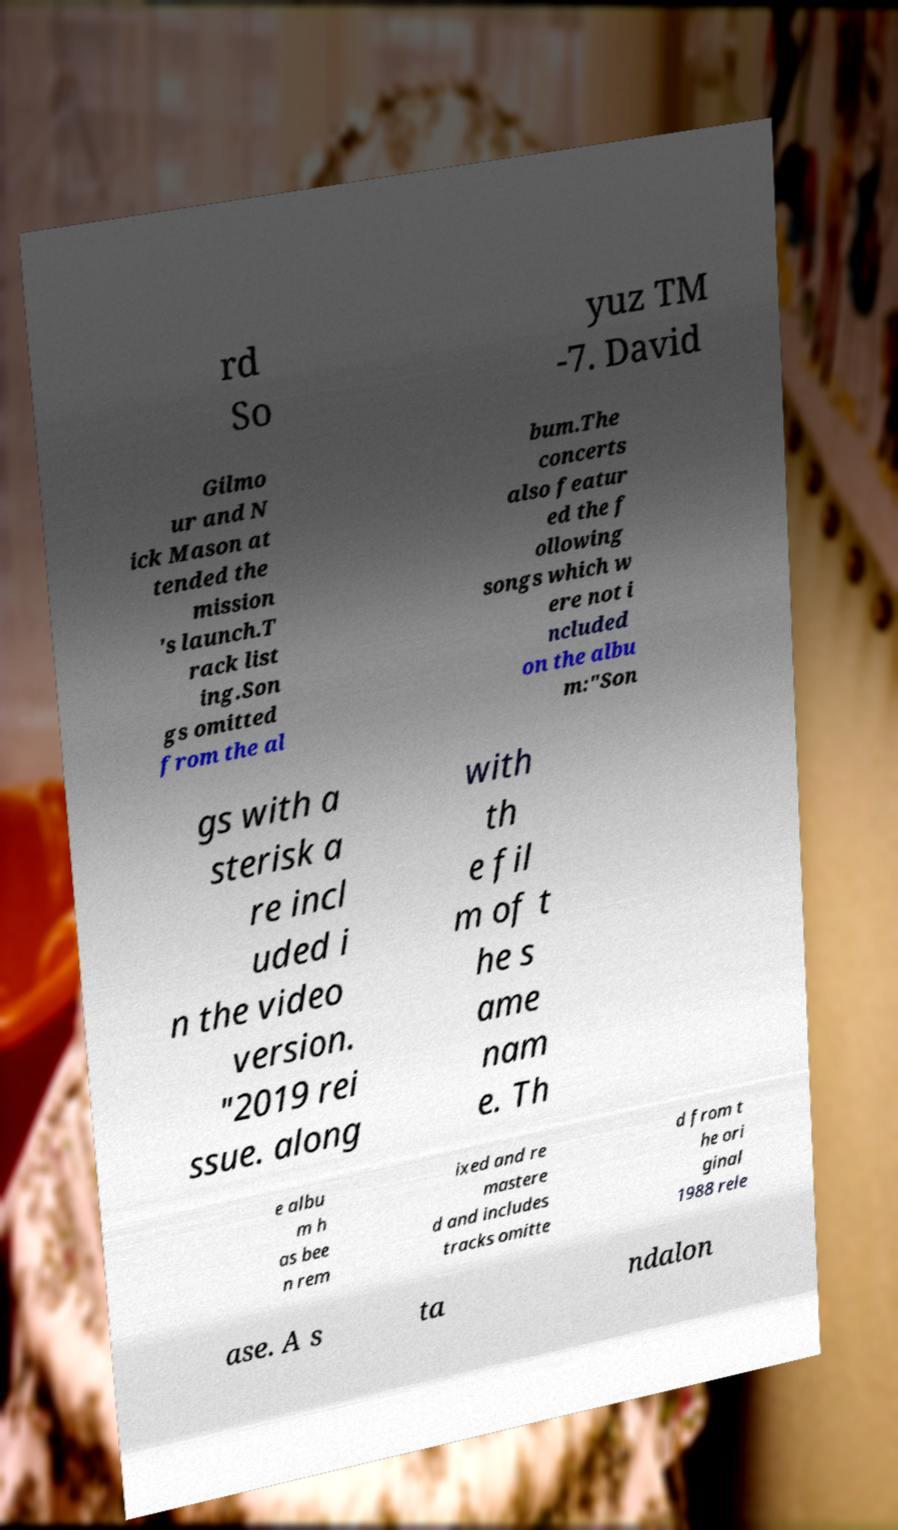Could you assist in decoding the text presented in this image and type it out clearly? rd So yuz TM -7. David Gilmo ur and N ick Mason at tended the mission 's launch.T rack list ing.Son gs omitted from the al bum.The concerts also featur ed the f ollowing songs which w ere not i ncluded on the albu m:"Son gs with a sterisk a re incl uded i n the video version. "2019 rei ssue. along with th e fil m of t he s ame nam e. Th e albu m h as bee n rem ixed and re mastere d and includes tracks omitte d from t he ori ginal 1988 rele ase. A s ta ndalon 